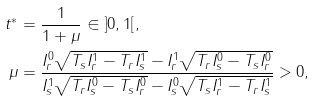Convert formula to latex. <formula><loc_0><loc_0><loc_500><loc_500>t ^ { * } & = \frac { 1 } { 1 + \mu } \in { ] 0 , 1 [ } , \\ \mu & = \frac { I _ { r } ^ { 0 } \sqrt { T _ { s } I _ { r } ^ { 1 } - T _ { r } I _ { s } ^ { 1 } } - I _ { r } ^ { 1 } \sqrt { T _ { r } I _ { s } ^ { 0 } - T _ { s } I _ { r } ^ { 0 } } } { I _ { s } ^ { 1 } \sqrt { T _ { r } I _ { s } ^ { 0 } - T _ { s } I _ { r } ^ { 0 } } - I ^ { 0 } _ { s } \sqrt { T _ { s } I _ { r } ^ { 1 } - T _ { r } I _ { s } ^ { 1 } } } > 0 ,</formula> 